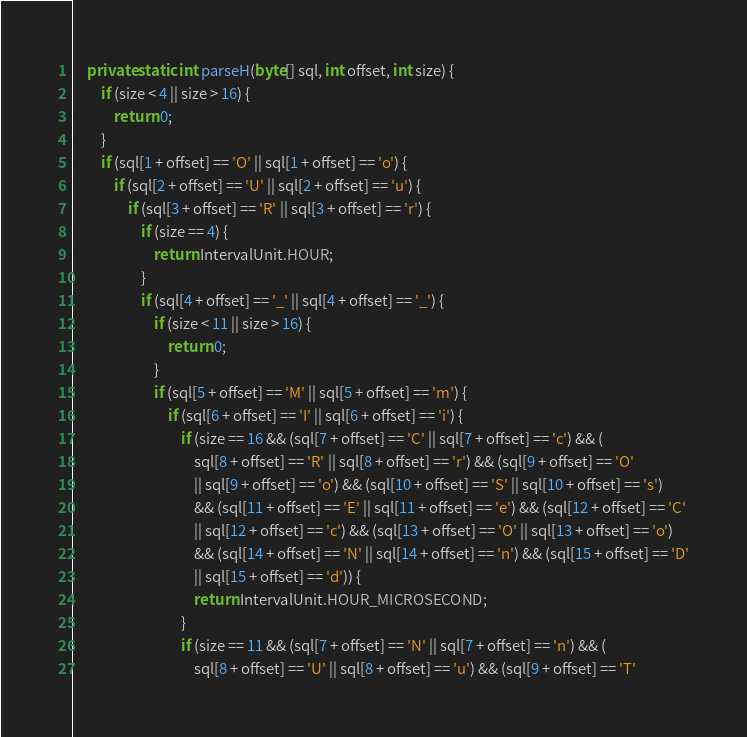Convert code to text. <code><loc_0><loc_0><loc_500><loc_500><_Java_>
    private static int parseH(byte[] sql, int offset, int size) {
        if (size < 4 || size > 16) {
            return 0;
        }
        if (sql[1 + offset] == 'O' || sql[1 + offset] == 'o') {
            if (sql[2 + offset] == 'U' || sql[2 + offset] == 'u') {
                if (sql[3 + offset] == 'R' || sql[3 + offset] == 'r') {
                    if (size == 4) {
                        return IntervalUnit.HOUR;
                    }
                    if (sql[4 + offset] == '_' || sql[4 + offset] == '_') {
                        if (size < 11 || size > 16) {
                            return 0;
                        }
                        if (sql[5 + offset] == 'M' || sql[5 + offset] == 'm') {
                            if (sql[6 + offset] == 'I' || sql[6 + offset] == 'i') {
                                if (size == 16 && (sql[7 + offset] == 'C' || sql[7 + offset] == 'c') && (
                                    sql[8 + offset] == 'R' || sql[8 + offset] == 'r') && (sql[9 + offset] == 'O'
                                    || sql[9 + offset] == 'o') && (sql[10 + offset] == 'S' || sql[10 + offset] == 's')
                                    && (sql[11 + offset] == 'E' || sql[11 + offset] == 'e') && (sql[12 + offset] == 'C'
                                    || sql[12 + offset] == 'c') && (sql[13 + offset] == 'O' || sql[13 + offset] == 'o')
                                    && (sql[14 + offset] == 'N' || sql[14 + offset] == 'n') && (sql[15 + offset] == 'D'
                                    || sql[15 + offset] == 'd')) {
                                    return IntervalUnit.HOUR_MICROSECOND;
                                }
                                if (size == 11 && (sql[7 + offset] == 'N' || sql[7 + offset] == 'n') && (
                                    sql[8 + offset] == 'U' || sql[8 + offset] == 'u') && (sql[9 + offset] == 'T'</code> 